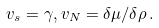Convert formula to latex. <formula><loc_0><loc_0><loc_500><loc_500>v _ { s } = \gamma , v _ { N } = \delta \mu / \delta \rho \, .</formula> 